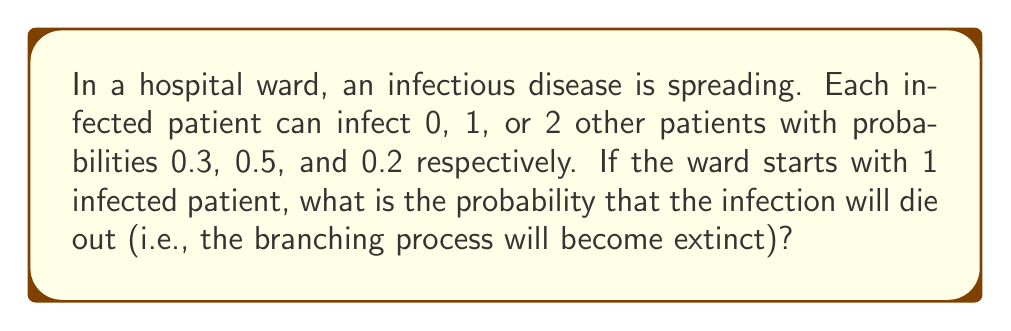Show me your answer to this math problem. To solve this problem, we'll use the theory of branching processes:

1) Let $q$ be the probability of extinction. We need to find $q$.

2) In a branching process, $q$ satisfies the equation:
   $q = f(q)$, where $f(s)$ is the probability generating function of the offspring distribution.

3) In this case, $f(s) = 0.3 + 0.5s + 0.2s^2$

4) So, we need to solve the equation:
   $q = 0.3 + 0.5q + 0.2q^2$

5) Rearranging:
   $0.2q^2 + 0.5q + 0.3 - q = 0$
   $0.2q^2 - 0.5q + 0.3 = 0$

6) This is a quadratic equation. We can solve it using the quadratic formula:
   $q = \frac{-b \pm \sqrt{b^2 - 4ac}}{2a}$

   Where $a = 0.2$, $b = -0.5$, and $c = 0.3$

7) Substituting:
   $q = \frac{0.5 \pm \sqrt{(-0.5)^2 - 4(0.2)(0.3)}}{2(0.2)}$
   $= \frac{0.5 \pm \sqrt{0.25 - 0.24}}{0.4}$
   $= \frac{0.5 \pm \sqrt{0.01}}{0.4}$
   $= \frac{0.5 \pm 0.1}{0.4}$

8) This gives us two solutions: $q = 1.5$ or $q = 1$

9) Since $q$ is a probability, it must be between 0 and 1 inclusive. Therefore, $q = 1$ is the only valid solution.
Answer: 1 